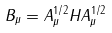Convert formula to latex. <formula><loc_0><loc_0><loc_500><loc_500>B _ { \mu } = A _ { \mu } ^ { 1 / 2 } H A _ { \mu } ^ { 1 / 2 }</formula> 